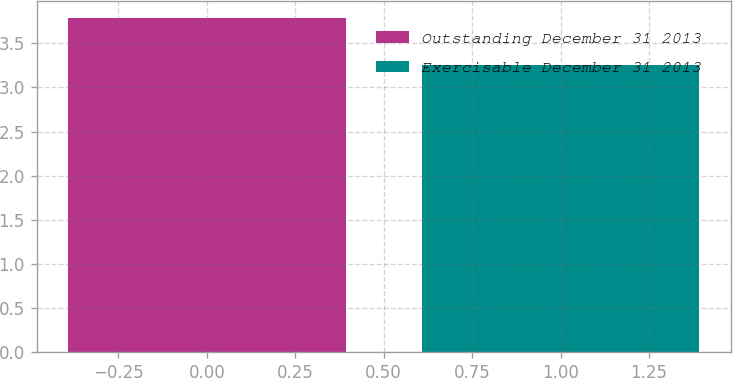Convert chart. <chart><loc_0><loc_0><loc_500><loc_500><bar_chart><fcel>Outstanding December 31 2013<fcel>Exercisable December 31 2013<nl><fcel>3.79<fcel>3.25<nl></chart> 